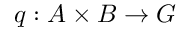Convert formula to latex. <formula><loc_0><loc_0><loc_500><loc_500>q \colon A \times B \to G</formula> 